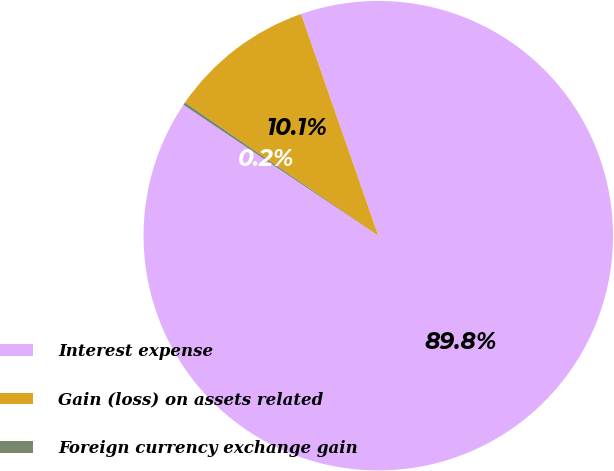Convert chart. <chart><loc_0><loc_0><loc_500><loc_500><pie_chart><fcel>Interest expense<fcel>Gain (loss) on assets related<fcel>Foreign currency exchange gain<nl><fcel>89.75%<fcel>10.06%<fcel>0.19%<nl></chart> 